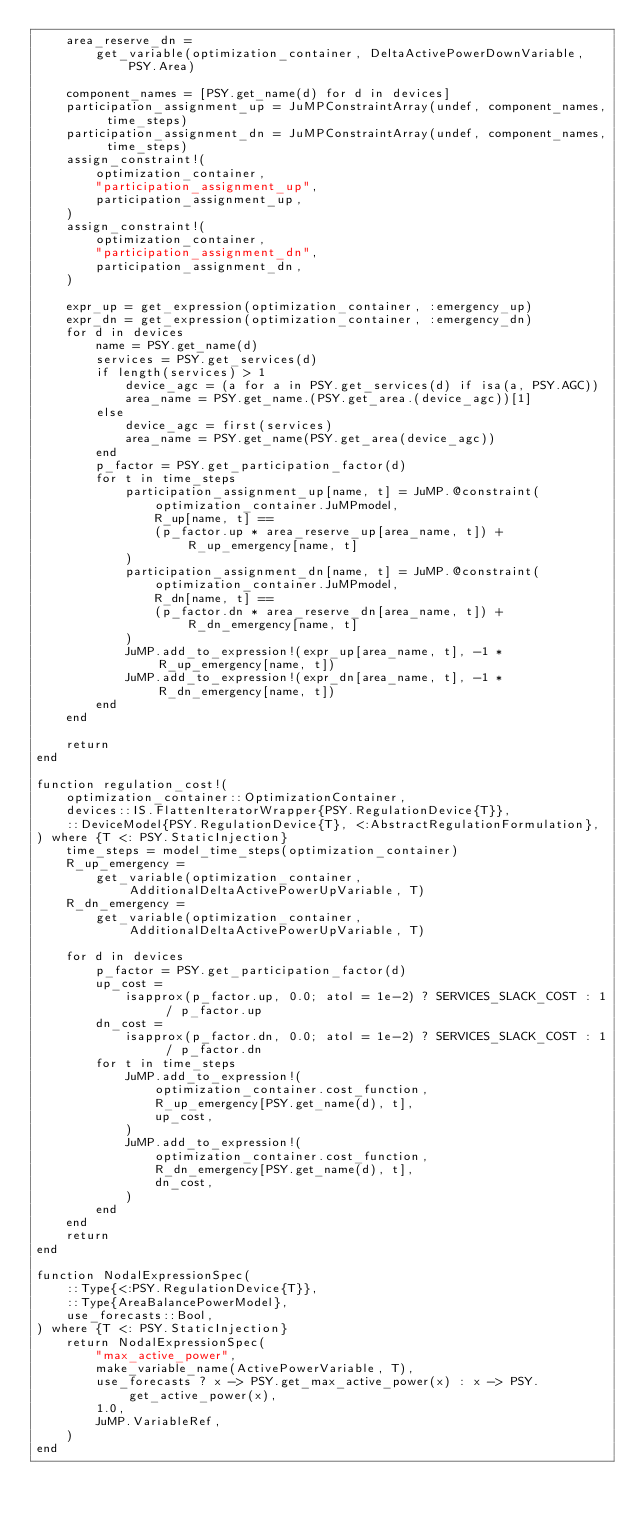Convert code to text. <code><loc_0><loc_0><loc_500><loc_500><_Julia_>    area_reserve_dn =
        get_variable(optimization_container, DeltaActivePowerDownVariable, PSY.Area)

    component_names = [PSY.get_name(d) for d in devices]
    participation_assignment_up = JuMPConstraintArray(undef, component_names, time_steps)
    participation_assignment_dn = JuMPConstraintArray(undef, component_names, time_steps)
    assign_constraint!(
        optimization_container,
        "participation_assignment_up",
        participation_assignment_up,
    )
    assign_constraint!(
        optimization_container,
        "participation_assignment_dn",
        participation_assignment_dn,
    )

    expr_up = get_expression(optimization_container, :emergency_up)
    expr_dn = get_expression(optimization_container, :emergency_dn)
    for d in devices
        name = PSY.get_name(d)
        services = PSY.get_services(d)
        if length(services) > 1
            device_agc = (a for a in PSY.get_services(d) if isa(a, PSY.AGC))
            area_name = PSY.get_name.(PSY.get_area.(device_agc))[1]
        else
            device_agc = first(services)
            area_name = PSY.get_name(PSY.get_area(device_agc))
        end
        p_factor = PSY.get_participation_factor(d)
        for t in time_steps
            participation_assignment_up[name, t] = JuMP.@constraint(
                optimization_container.JuMPmodel,
                R_up[name, t] ==
                (p_factor.up * area_reserve_up[area_name, t]) + R_up_emergency[name, t]
            )
            participation_assignment_dn[name, t] = JuMP.@constraint(
                optimization_container.JuMPmodel,
                R_dn[name, t] ==
                (p_factor.dn * area_reserve_dn[area_name, t]) + R_dn_emergency[name, t]
            )
            JuMP.add_to_expression!(expr_up[area_name, t], -1 * R_up_emergency[name, t])
            JuMP.add_to_expression!(expr_dn[area_name, t], -1 * R_dn_emergency[name, t])
        end
    end

    return
end

function regulation_cost!(
    optimization_container::OptimizationContainer,
    devices::IS.FlattenIteratorWrapper{PSY.RegulationDevice{T}},
    ::DeviceModel{PSY.RegulationDevice{T}, <:AbstractRegulationFormulation},
) where {T <: PSY.StaticInjection}
    time_steps = model_time_steps(optimization_container)
    R_up_emergency =
        get_variable(optimization_container, AdditionalDeltaActivePowerUpVariable, T)
    R_dn_emergency =
        get_variable(optimization_container, AdditionalDeltaActivePowerUpVariable, T)

    for d in devices
        p_factor = PSY.get_participation_factor(d)
        up_cost =
            isapprox(p_factor.up, 0.0; atol = 1e-2) ? SERVICES_SLACK_COST : 1 / p_factor.up
        dn_cost =
            isapprox(p_factor.dn, 0.0; atol = 1e-2) ? SERVICES_SLACK_COST : 1 / p_factor.dn
        for t in time_steps
            JuMP.add_to_expression!(
                optimization_container.cost_function,
                R_up_emergency[PSY.get_name(d), t],
                up_cost,
            )
            JuMP.add_to_expression!(
                optimization_container.cost_function,
                R_dn_emergency[PSY.get_name(d), t],
                dn_cost,
            )
        end
    end
    return
end

function NodalExpressionSpec(
    ::Type{<:PSY.RegulationDevice{T}},
    ::Type{AreaBalancePowerModel},
    use_forecasts::Bool,
) where {T <: PSY.StaticInjection}
    return NodalExpressionSpec(
        "max_active_power",
        make_variable_name(ActivePowerVariable, T),
        use_forecasts ? x -> PSY.get_max_active_power(x) : x -> PSY.get_active_power(x),
        1.0,
        JuMP.VariableRef,
    )
end
</code> 